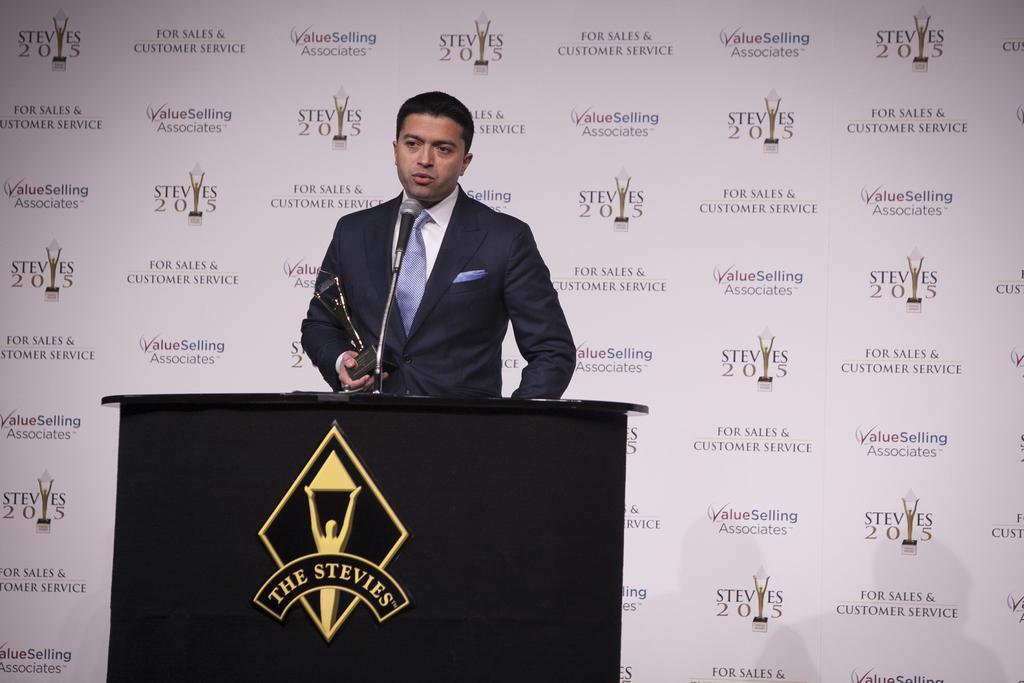Could you give a brief overview of what you see in this image? In the foreground of this image, there is a man holding an award is standing in front of a podium on which there is a mic. In the background, there is a banner wall. 